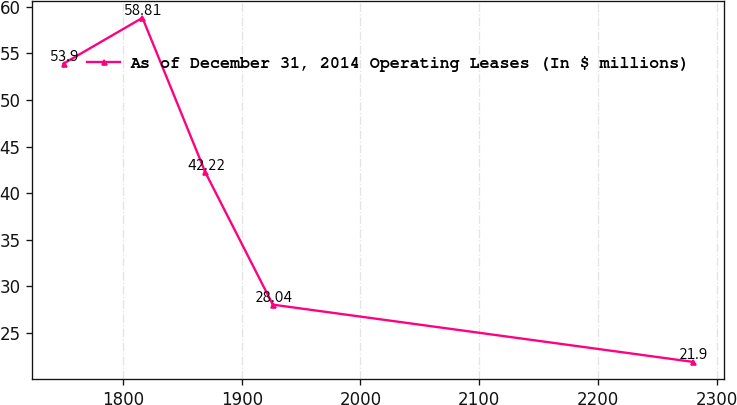<chart> <loc_0><loc_0><loc_500><loc_500><line_chart><ecel><fcel>As of December 31, 2014 Operating Leases (In $ millions)<nl><fcel>1749.87<fcel>53.9<nl><fcel>1816.32<fcel>58.81<nl><fcel>1869.34<fcel>42.22<nl><fcel>1926.13<fcel>28.04<nl><fcel>2280.1<fcel>21.9<nl></chart> 